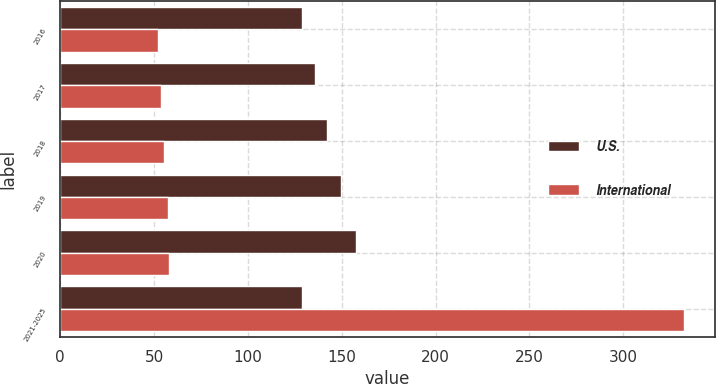Convert chart to OTSL. <chart><loc_0><loc_0><loc_500><loc_500><stacked_bar_chart><ecel><fcel>2016<fcel>2017<fcel>2018<fcel>2019<fcel>2020<fcel>2021-2025<nl><fcel>U.S.<fcel>129<fcel>135.8<fcel>142.2<fcel>149.6<fcel>157.4<fcel>129<nl><fcel>International<fcel>52<fcel>53.5<fcel>55.3<fcel>57.5<fcel>57.8<fcel>332.3<nl></chart> 